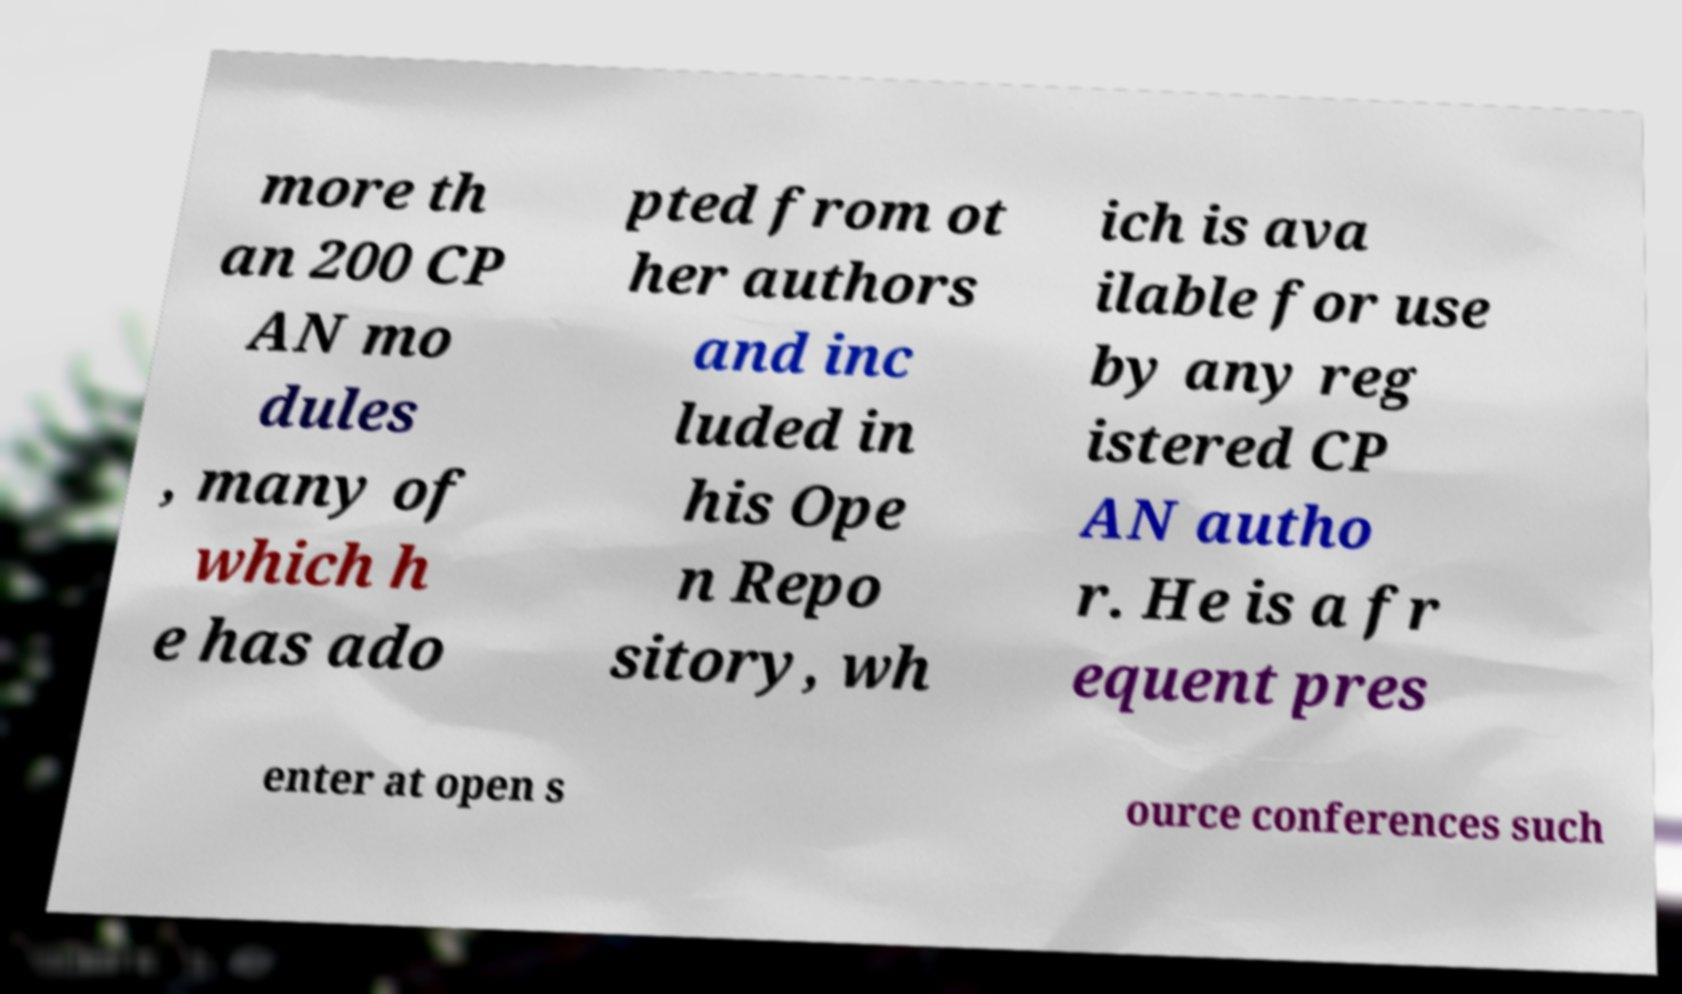Please read and relay the text visible in this image. What does it say? more th an 200 CP AN mo dules , many of which h e has ado pted from ot her authors and inc luded in his Ope n Repo sitory, wh ich is ava ilable for use by any reg istered CP AN autho r. He is a fr equent pres enter at open s ource conferences such 